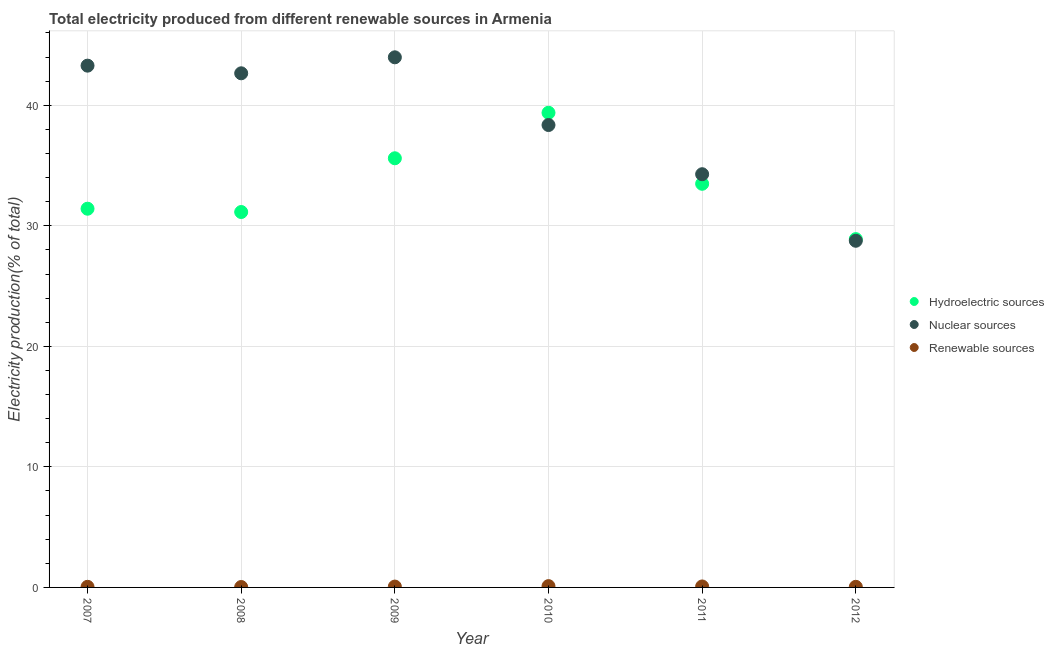How many different coloured dotlines are there?
Offer a terse response. 3. What is the percentage of electricity produced by hydroelectric sources in 2012?
Give a very brief answer. 28.89. Across all years, what is the maximum percentage of electricity produced by hydroelectric sources?
Give a very brief answer. 39.38. Across all years, what is the minimum percentage of electricity produced by hydroelectric sources?
Offer a terse response. 28.89. In which year was the percentage of electricity produced by hydroelectric sources maximum?
Your answer should be compact. 2010. What is the total percentage of electricity produced by hydroelectric sources in the graph?
Your answer should be compact. 199.92. What is the difference between the percentage of electricity produced by nuclear sources in 2011 and that in 2012?
Provide a succinct answer. 5.52. What is the difference between the percentage of electricity produced by nuclear sources in 2011 and the percentage of electricity produced by renewable sources in 2009?
Your response must be concise. 34.21. What is the average percentage of electricity produced by renewable sources per year?
Make the answer very short. 0.07. In the year 2012, what is the difference between the percentage of electricity produced by nuclear sources and percentage of electricity produced by hydroelectric sources?
Provide a short and direct response. -0.14. What is the ratio of the percentage of electricity produced by renewable sources in 2007 to that in 2012?
Your answer should be very brief. 1.02. Is the difference between the percentage of electricity produced by hydroelectric sources in 2011 and 2012 greater than the difference between the percentage of electricity produced by nuclear sources in 2011 and 2012?
Provide a short and direct response. No. What is the difference between the highest and the second highest percentage of electricity produced by renewable sources?
Your response must be concise. 0.03. What is the difference between the highest and the lowest percentage of electricity produced by renewable sources?
Make the answer very short. 0.07. Is the sum of the percentage of electricity produced by nuclear sources in 2007 and 2010 greater than the maximum percentage of electricity produced by renewable sources across all years?
Your response must be concise. Yes. How many dotlines are there?
Your answer should be compact. 3. How many years are there in the graph?
Provide a succinct answer. 6. What is the difference between two consecutive major ticks on the Y-axis?
Ensure brevity in your answer.  10. Are the values on the major ticks of Y-axis written in scientific E-notation?
Keep it short and to the point. No. How many legend labels are there?
Your response must be concise. 3. How are the legend labels stacked?
Your response must be concise. Vertical. What is the title of the graph?
Your response must be concise. Total electricity produced from different renewable sources in Armenia. What is the label or title of the X-axis?
Your response must be concise. Year. What is the label or title of the Y-axis?
Offer a very short reply. Electricity production(% of total). What is the Electricity production(% of total) in Hydroelectric sources in 2007?
Ensure brevity in your answer.  31.42. What is the Electricity production(% of total) in Nuclear sources in 2007?
Make the answer very short. 43.29. What is the Electricity production(% of total) in Renewable sources in 2007?
Provide a succinct answer. 0.05. What is the Electricity production(% of total) in Hydroelectric sources in 2008?
Your answer should be compact. 31.14. What is the Electricity production(% of total) of Nuclear sources in 2008?
Ensure brevity in your answer.  42.65. What is the Electricity production(% of total) of Renewable sources in 2008?
Your answer should be very brief. 0.03. What is the Electricity production(% of total) in Hydroelectric sources in 2009?
Provide a succinct answer. 35.6. What is the Electricity production(% of total) in Nuclear sources in 2009?
Keep it short and to the point. 43.98. What is the Electricity production(% of total) of Renewable sources in 2009?
Provide a short and direct response. 0.07. What is the Electricity production(% of total) in Hydroelectric sources in 2010?
Offer a terse response. 39.38. What is the Electricity production(% of total) in Nuclear sources in 2010?
Your answer should be very brief. 38.36. What is the Electricity production(% of total) in Renewable sources in 2010?
Offer a very short reply. 0.11. What is the Electricity production(% of total) in Hydroelectric sources in 2011?
Provide a succinct answer. 33.49. What is the Electricity production(% of total) in Nuclear sources in 2011?
Provide a short and direct response. 34.28. What is the Electricity production(% of total) of Renewable sources in 2011?
Offer a very short reply. 0.08. What is the Electricity production(% of total) in Hydroelectric sources in 2012?
Your response must be concise. 28.89. What is the Electricity production(% of total) in Nuclear sources in 2012?
Make the answer very short. 28.76. What is the Electricity production(% of total) of Renewable sources in 2012?
Keep it short and to the point. 0.05. Across all years, what is the maximum Electricity production(% of total) of Hydroelectric sources?
Your response must be concise. 39.38. Across all years, what is the maximum Electricity production(% of total) in Nuclear sources?
Your response must be concise. 43.98. Across all years, what is the maximum Electricity production(% of total) in Renewable sources?
Keep it short and to the point. 0.11. Across all years, what is the minimum Electricity production(% of total) of Hydroelectric sources?
Make the answer very short. 28.89. Across all years, what is the minimum Electricity production(% of total) in Nuclear sources?
Ensure brevity in your answer.  28.76. Across all years, what is the minimum Electricity production(% of total) in Renewable sources?
Offer a very short reply. 0.03. What is the total Electricity production(% of total) in Hydroelectric sources in the graph?
Make the answer very short. 199.92. What is the total Electricity production(% of total) of Nuclear sources in the graph?
Offer a very short reply. 231.31. What is the total Electricity production(% of total) of Renewable sources in the graph?
Your response must be concise. 0.39. What is the difference between the Electricity production(% of total) of Hydroelectric sources in 2007 and that in 2008?
Ensure brevity in your answer.  0.27. What is the difference between the Electricity production(% of total) of Nuclear sources in 2007 and that in 2008?
Provide a succinct answer. 0.63. What is the difference between the Electricity production(% of total) of Renewable sources in 2007 and that in 2008?
Provide a succinct answer. 0.02. What is the difference between the Electricity production(% of total) in Hydroelectric sources in 2007 and that in 2009?
Offer a very short reply. -4.18. What is the difference between the Electricity production(% of total) of Nuclear sources in 2007 and that in 2009?
Your answer should be compact. -0.69. What is the difference between the Electricity production(% of total) of Renewable sources in 2007 and that in 2009?
Your answer should be very brief. -0.02. What is the difference between the Electricity production(% of total) in Hydroelectric sources in 2007 and that in 2010?
Your answer should be compact. -7.96. What is the difference between the Electricity production(% of total) in Nuclear sources in 2007 and that in 2010?
Make the answer very short. 4.93. What is the difference between the Electricity production(% of total) in Renewable sources in 2007 and that in 2010?
Give a very brief answer. -0.06. What is the difference between the Electricity production(% of total) in Hydroelectric sources in 2007 and that in 2011?
Your answer should be compact. -2.07. What is the difference between the Electricity production(% of total) in Nuclear sources in 2007 and that in 2011?
Provide a succinct answer. 9.01. What is the difference between the Electricity production(% of total) in Renewable sources in 2007 and that in 2011?
Provide a succinct answer. -0.03. What is the difference between the Electricity production(% of total) in Hydroelectric sources in 2007 and that in 2012?
Your answer should be compact. 2.52. What is the difference between the Electricity production(% of total) in Nuclear sources in 2007 and that in 2012?
Keep it short and to the point. 14.53. What is the difference between the Electricity production(% of total) of Renewable sources in 2007 and that in 2012?
Provide a short and direct response. 0. What is the difference between the Electricity production(% of total) in Hydroelectric sources in 2008 and that in 2009?
Provide a succinct answer. -4.46. What is the difference between the Electricity production(% of total) in Nuclear sources in 2008 and that in 2009?
Provide a succinct answer. -1.33. What is the difference between the Electricity production(% of total) in Renewable sources in 2008 and that in 2009?
Provide a short and direct response. -0.04. What is the difference between the Electricity production(% of total) in Hydroelectric sources in 2008 and that in 2010?
Offer a terse response. -8.23. What is the difference between the Electricity production(% of total) of Nuclear sources in 2008 and that in 2010?
Provide a short and direct response. 4.29. What is the difference between the Electricity production(% of total) in Renewable sources in 2008 and that in 2010?
Give a very brief answer. -0.07. What is the difference between the Electricity production(% of total) in Hydroelectric sources in 2008 and that in 2011?
Keep it short and to the point. -2.34. What is the difference between the Electricity production(% of total) of Nuclear sources in 2008 and that in 2011?
Your answer should be very brief. 8.37. What is the difference between the Electricity production(% of total) in Renewable sources in 2008 and that in 2011?
Make the answer very short. -0.05. What is the difference between the Electricity production(% of total) in Hydroelectric sources in 2008 and that in 2012?
Your response must be concise. 2.25. What is the difference between the Electricity production(% of total) in Nuclear sources in 2008 and that in 2012?
Provide a succinct answer. 13.89. What is the difference between the Electricity production(% of total) of Renewable sources in 2008 and that in 2012?
Your answer should be compact. -0.02. What is the difference between the Electricity production(% of total) in Hydroelectric sources in 2009 and that in 2010?
Ensure brevity in your answer.  -3.78. What is the difference between the Electricity production(% of total) of Nuclear sources in 2009 and that in 2010?
Your answer should be very brief. 5.62. What is the difference between the Electricity production(% of total) in Renewable sources in 2009 and that in 2010?
Your answer should be compact. -0.04. What is the difference between the Electricity production(% of total) of Hydroelectric sources in 2009 and that in 2011?
Ensure brevity in your answer.  2.12. What is the difference between the Electricity production(% of total) of Nuclear sources in 2009 and that in 2011?
Offer a very short reply. 9.7. What is the difference between the Electricity production(% of total) of Renewable sources in 2009 and that in 2011?
Your response must be concise. -0.01. What is the difference between the Electricity production(% of total) in Hydroelectric sources in 2009 and that in 2012?
Keep it short and to the point. 6.71. What is the difference between the Electricity production(% of total) in Nuclear sources in 2009 and that in 2012?
Your answer should be very brief. 15.22. What is the difference between the Electricity production(% of total) of Renewable sources in 2009 and that in 2012?
Ensure brevity in your answer.  0.02. What is the difference between the Electricity production(% of total) of Hydroelectric sources in 2010 and that in 2011?
Make the answer very short. 5.89. What is the difference between the Electricity production(% of total) of Nuclear sources in 2010 and that in 2011?
Your answer should be compact. 4.08. What is the difference between the Electricity production(% of total) of Renewable sources in 2010 and that in 2011?
Offer a terse response. 0.03. What is the difference between the Electricity production(% of total) in Hydroelectric sources in 2010 and that in 2012?
Provide a succinct answer. 10.48. What is the difference between the Electricity production(% of total) in Nuclear sources in 2010 and that in 2012?
Keep it short and to the point. 9.6. What is the difference between the Electricity production(% of total) in Renewable sources in 2010 and that in 2012?
Provide a succinct answer. 0.06. What is the difference between the Electricity production(% of total) in Hydroelectric sources in 2011 and that in 2012?
Your answer should be very brief. 4.59. What is the difference between the Electricity production(% of total) in Nuclear sources in 2011 and that in 2012?
Your answer should be compact. 5.52. What is the difference between the Electricity production(% of total) in Renewable sources in 2011 and that in 2012?
Provide a succinct answer. 0.03. What is the difference between the Electricity production(% of total) in Hydroelectric sources in 2007 and the Electricity production(% of total) in Nuclear sources in 2008?
Offer a very short reply. -11.23. What is the difference between the Electricity production(% of total) in Hydroelectric sources in 2007 and the Electricity production(% of total) in Renewable sources in 2008?
Offer a very short reply. 31.38. What is the difference between the Electricity production(% of total) in Nuclear sources in 2007 and the Electricity production(% of total) in Renewable sources in 2008?
Offer a very short reply. 43.25. What is the difference between the Electricity production(% of total) in Hydroelectric sources in 2007 and the Electricity production(% of total) in Nuclear sources in 2009?
Keep it short and to the point. -12.56. What is the difference between the Electricity production(% of total) of Hydroelectric sources in 2007 and the Electricity production(% of total) of Renewable sources in 2009?
Your answer should be compact. 31.35. What is the difference between the Electricity production(% of total) in Nuclear sources in 2007 and the Electricity production(% of total) in Renewable sources in 2009?
Provide a succinct answer. 43.22. What is the difference between the Electricity production(% of total) in Hydroelectric sources in 2007 and the Electricity production(% of total) in Nuclear sources in 2010?
Give a very brief answer. -6.94. What is the difference between the Electricity production(% of total) in Hydroelectric sources in 2007 and the Electricity production(% of total) in Renewable sources in 2010?
Your answer should be very brief. 31.31. What is the difference between the Electricity production(% of total) of Nuclear sources in 2007 and the Electricity production(% of total) of Renewable sources in 2010?
Your answer should be compact. 43.18. What is the difference between the Electricity production(% of total) of Hydroelectric sources in 2007 and the Electricity production(% of total) of Nuclear sources in 2011?
Keep it short and to the point. -2.86. What is the difference between the Electricity production(% of total) in Hydroelectric sources in 2007 and the Electricity production(% of total) in Renewable sources in 2011?
Ensure brevity in your answer.  31.34. What is the difference between the Electricity production(% of total) in Nuclear sources in 2007 and the Electricity production(% of total) in Renewable sources in 2011?
Your answer should be compact. 43.21. What is the difference between the Electricity production(% of total) of Hydroelectric sources in 2007 and the Electricity production(% of total) of Nuclear sources in 2012?
Give a very brief answer. 2.66. What is the difference between the Electricity production(% of total) of Hydroelectric sources in 2007 and the Electricity production(% of total) of Renewable sources in 2012?
Keep it short and to the point. 31.37. What is the difference between the Electricity production(% of total) in Nuclear sources in 2007 and the Electricity production(% of total) in Renewable sources in 2012?
Offer a terse response. 43.24. What is the difference between the Electricity production(% of total) in Hydroelectric sources in 2008 and the Electricity production(% of total) in Nuclear sources in 2009?
Provide a succinct answer. -12.83. What is the difference between the Electricity production(% of total) of Hydroelectric sources in 2008 and the Electricity production(% of total) of Renewable sources in 2009?
Provide a short and direct response. 31.07. What is the difference between the Electricity production(% of total) of Nuclear sources in 2008 and the Electricity production(% of total) of Renewable sources in 2009?
Offer a terse response. 42.58. What is the difference between the Electricity production(% of total) in Hydroelectric sources in 2008 and the Electricity production(% of total) in Nuclear sources in 2010?
Keep it short and to the point. -7.22. What is the difference between the Electricity production(% of total) in Hydroelectric sources in 2008 and the Electricity production(% of total) in Renewable sources in 2010?
Your answer should be compact. 31.04. What is the difference between the Electricity production(% of total) of Nuclear sources in 2008 and the Electricity production(% of total) of Renewable sources in 2010?
Your response must be concise. 42.54. What is the difference between the Electricity production(% of total) of Hydroelectric sources in 2008 and the Electricity production(% of total) of Nuclear sources in 2011?
Your answer should be very brief. -3.14. What is the difference between the Electricity production(% of total) in Hydroelectric sources in 2008 and the Electricity production(% of total) in Renewable sources in 2011?
Your response must be concise. 31.06. What is the difference between the Electricity production(% of total) in Nuclear sources in 2008 and the Electricity production(% of total) in Renewable sources in 2011?
Give a very brief answer. 42.57. What is the difference between the Electricity production(% of total) in Hydroelectric sources in 2008 and the Electricity production(% of total) in Nuclear sources in 2012?
Provide a short and direct response. 2.39. What is the difference between the Electricity production(% of total) of Hydroelectric sources in 2008 and the Electricity production(% of total) of Renewable sources in 2012?
Your answer should be compact. 31.09. What is the difference between the Electricity production(% of total) in Nuclear sources in 2008 and the Electricity production(% of total) in Renewable sources in 2012?
Ensure brevity in your answer.  42.6. What is the difference between the Electricity production(% of total) of Hydroelectric sources in 2009 and the Electricity production(% of total) of Nuclear sources in 2010?
Provide a short and direct response. -2.76. What is the difference between the Electricity production(% of total) in Hydroelectric sources in 2009 and the Electricity production(% of total) in Renewable sources in 2010?
Provide a short and direct response. 35.49. What is the difference between the Electricity production(% of total) in Nuclear sources in 2009 and the Electricity production(% of total) in Renewable sources in 2010?
Provide a short and direct response. 43.87. What is the difference between the Electricity production(% of total) of Hydroelectric sources in 2009 and the Electricity production(% of total) of Nuclear sources in 2011?
Your response must be concise. 1.32. What is the difference between the Electricity production(% of total) in Hydroelectric sources in 2009 and the Electricity production(% of total) in Renewable sources in 2011?
Make the answer very short. 35.52. What is the difference between the Electricity production(% of total) in Nuclear sources in 2009 and the Electricity production(% of total) in Renewable sources in 2011?
Your answer should be compact. 43.9. What is the difference between the Electricity production(% of total) in Hydroelectric sources in 2009 and the Electricity production(% of total) in Nuclear sources in 2012?
Keep it short and to the point. 6.84. What is the difference between the Electricity production(% of total) of Hydroelectric sources in 2009 and the Electricity production(% of total) of Renewable sources in 2012?
Provide a short and direct response. 35.55. What is the difference between the Electricity production(% of total) in Nuclear sources in 2009 and the Electricity production(% of total) in Renewable sources in 2012?
Your answer should be compact. 43.93. What is the difference between the Electricity production(% of total) in Hydroelectric sources in 2010 and the Electricity production(% of total) in Nuclear sources in 2011?
Offer a terse response. 5.1. What is the difference between the Electricity production(% of total) in Hydroelectric sources in 2010 and the Electricity production(% of total) in Renewable sources in 2011?
Make the answer very short. 39.3. What is the difference between the Electricity production(% of total) in Nuclear sources in 2010 and the Electricity production(% of total) in Renewable sources in 2011?
Offer a terse response. 38.28. What is the difference between the Electricity production(% of total) of Hydroelectric sources in 2010 and the Electricity production(% of total) of Nuclear sources in 2012?
Ensure brevity in your answer.  10.62. What is the difference between the Electricity production(% of total) of Hydroelectric sources in 2010 and the Electricity production(% of total) of Renewable sources in 2012?
Your answer should be compact. 39.33. What is the difference between the Electricity production(% of total) of Nuclear sources in 2010 and the Electricity production(% of total) of Renewable sources in 2012?
Make the answer very short. 38.31. What is the difference between the Electricity production(% of total) in Hydroelectric sources in 2011 and the Electricity production(% of total) in Nuclear sources in 2012?
Your answer should be very brief. 4.73. What is the difference between the Electricity production(% of total) in Hydroelectric sources in 2011 and the Electricity production(% of total) in Renewable sources in 2012?
Provide a succinct answer. 33.44. What is the difference between the Electricity production(% of total) of Nuclear sources in 2011 and the Electricity production(% of total) of Renewable sources in 2012?
Offer a terse response. 34.23. What is the average Electricity production(% of total) of Hydroelectric sources per year?
Ensure brevity in your answer.  33.32. What is the average Electricity production(% of total) of Nuclear sources per year?
Make the answer very short. 38.55. What is the average Electricity production(% of total) of Renewable sources per year?
Your response must be concise. 0.07. In the year 2007, what is the difference between the Electricity production(% of total) of Hydroelectric sources and Electricity production(% of total) of Nuclear sources?
Provide a short and direct response. -11.87. In the year 2007, what is the difference between the Electricity production(% of total) of Hydroelectric sources and Electricity production(% of total) of Renewable sources?
Keep it short and to the point. 31.37. In the year 2007, what is the difference between the Electricity production(% of total) of Nuclear sources and Electricity production(% of total) of Renewable sources?
Offer a terse response. 43.23. In the year 2008, what is the difference between the Electricity production(% of total) of Hydroelectric sources and Electricity production(% of total) of Nuclear sources?
Provide a succinct answer. -11.51. In the year 2008, what is the difference between the Electricity production(% of total) in Hydroelectric sources and Electricity production(% of total) in Renewable sources?
Offer a very short reply. 31.11. In the year 2008, what is the difference between the Electricity production(% of total) of Nuclear sources and Electricity production(% of total) of Renewable sources?
Make the answer very short. 42.62. In the year 2009, what is the difference between the Electricity production(% of total) in Hydroelectric sources and Electricity production(% of total) in Nuclear sources?
Make the answer very short. -8.38. In the year 2009, what is the difference between the Electricity production(% of total) in Hydroelectric sources and Electricity production(% of total) in Renewable sources?
Make the answer very short. 35.53. In the year 2009, what is the difference between the Electricity production(% of total) of Nuclear sources and Electricity production(% of total) of Renewable sources?
Provide a succinct answer. 43.91. In the year 2010, what is the difference between the Electricity production(% of total) in Hydroelectric sources and Electricity production(% of total) in Nuclear sources?
Offer a terse response. 1.02. In the year 2010, what is the difference between the Electricity production(% of total) of Hydroelectric sources and Electricity production(% of total) of Renewable sources?
Provide a succinct answer. 39.27. In the year 2010, what is the difference between the Electricity production(% of total) of Nuclear sources and Electricity production(% of total) of Renewable sources?
Your response must be concise. 38.25. In the year 2011, what is the difference between the Electricity production(% of total) of Hydroelectric sources and Electricity production(% of total) of Nuclear sources?
Keep it short and to the point. -0.79. In the year 2011, what is the difference between the Electricity production(% of total) of Hydroelectric sources and Electricity production(% of total) of Renewable sources?
Ensure brevity in your answer.  33.41. In the year 2011, what is the difference between the Electricity production(% of total) of Nuclear sources and Electricity production(% of total) of Renewable sources?
Ensure brevity in your answer.  34.2. In the year 2012, what is the difference between the Electricity production(% of total) in Hydroelectric sources and Electricity production(% of total) in Nuclear sources?
Give a very brief answer. 0.14. In the year 2012, what is the difference between the Electricity production(% of total) of Hydroelectric sources and Electricity production(% of total) of Renewable sources?
Your answer should be compact. 28.85. In the year 2012, what is the difference between the Electricity production(% of total) of Nuclear sources and Electricity production(% of total) of Renewable sources?
Ensure brevity in your answer.  28.71. What is the ratio of the Electricity production(% of total) of Hydroelectric sources in 2007 to that in 2008?
Your answer should be compact. 1.01. What is the ratio of the Electricity production(% of total) of Nuclear sources in 2007 to that in 2008?
Your answer should be compact. 1.01. What is the ratio of the Electricity production(% of total) in Renewable sources in 2007 to that in 2008?
Your response must be concise. 1.47. What is the ratio of the Electricity production(% of total) in Hydroelectric sources in 2007 to that in 2009?
Provide a succinct answer. 0.88. What is the ratio of the Electricity production(% of total) of Nuclear sources in 2007 to that in 2009?
Make the answer very short. 0.98. What is the ratio of the Electricity production(% of total) in Renewable sources in 2007 to that in 2009?
Offer a very short reply. 0.72. What is the ratio of the Electricity production(% of total) in Hydroelectric sources in 2007 to that in 2010?
Keep it short and to the point. 0.8. What is the ratio of the Electricity production(% of total) of Nuclear sources in 2007 to that in 2010?
Offer a very short reply. 1.13. What is the ratio of the Electricity production(% of total) of Renewable sources in 2007 to that in 2010?
Your response must be concise. 0.47. What is the ratio of the Electricity production(% of total) in Hydroelectric sources in 2007 to that in 2011?
Your answer should be very brief. 0.94. What is the ratio of the Electricity production(% of total) in Nuclear sources in 2007 to that in 2011?
Offer a terse response. 1.26. What is the ratio of the Electricity production(% of total) of Renewable sources in 2007 to that in 2011?
Ensure brevity in your answer.  0.63. What is the ratio of the Electricity production(% of total) of Hydroelectric sources in 2007 to that in 2012?
Your answer should be compact. 1.09. What is the ratio of the Electricity production(% of total) in Nuclear sources in 2007 to that in 2012?
Ensure brevity in your answer.  1.51. What is the ratio of the Electricity production(% of total) of Renewable sources in 2007 to that in 2012?
Make the answer very short. 1.02. What is the ratio of the Electricity production(% of total) in Hydroelectric sources in 2008 to that in 2009?
Your answer should be compact. 0.87. What is the ratio of the Electricity production(% of total) of Nuclear sources in 2008 to that in 2009?
Offer a terse response. 0.97. What is the ratio of the Electricity production(% of total) in Renewable sources in 2008 to that in 2009?
Offer a terse response. 0.49. What is the ratio of the Electricity production(% of total) of Hydroelectric sources in 2008 to that in 2010?
Offer a very short reply. 0.79. What is the ratio of the Electricity production(% of total) of Nuclear sources in 2008 to that in 2010?
Provide a short and direct response. 1.11. What is the ratio of the Electricity production(% of total) in Renewable sources in 2008 to that in 2010?
Your answer should be compact. 0.32. What is the ratio of the Electricity production(% of total) in Hydroelectric sources in 2008 to that in 2011?
Keep it short and to the point. 0.93. What is the ratio of the Electricity production(% of total) in Nuclear sources in 2008 to that in 2011?
Your answer should be compact. 1.24. What is the ratio of the Electricity production(% of total) of Renewable sources in 2008 to that in 2011?
Offer a terse response. 0.43. What is the ratio of the Electricity production(% of total) of Hydroelectric sources in 2008 to that in 2012?
Ensure brevity in your answer.  1.08. What is the ratio of the Electricity production(% of total) of Nuclear sources in 2008 to that in 2012?
Keep it short and to the point. 1.48. What is the ratio of the Electricity production(% of total) in Renewable sources in 2008 to that in 2012?
Keep it short and to the point. 0.7. What is the ratio of the Electricity production(% of total) in Hydroelectric sources in 2009 to that in 2010?
Provide a short and direct response. 0.9. What is the ratio of the Electricity production(% of total) of Nuclear sources in 2009 to that in 2010?
Make the answer very short. 1.15. What is the ratio of the Electricity production(% of total) of Renewable sources in 2009 to that in 2010?
Ensure brevity in your answer.  0.65. What is the ratio of the Electricity production(% of total) in Hydroelectric sources in 2009 to that in 2011?
Offer a terse response. 1.06. What is the ratio of the Electricity production(% of total) of Nuclear sources in 2009 to that in 2011?
Your response must be concise. 1.28. What is the ratio of the Electricity production(% of total) of Renewable sources in 2009 to that in 2011?
Your response must be concise. 0.87. What is the ratio of the Electricity production(% of total) in Hydroelectric sources in 2009 to that in 2012?
Provide a succinct answer. 1.23. What is the ratio of the Electricity production(% of total) in Nuclear sources in 2009 to that in 2012?
Offer a terse response. 1.53. What is the ratio of the Electricity production(% of total) of Renewable sources in 2009 to that in 2012?
Offer a terse response. 1.42. What is the ratio of the Electricity production(% of total) in Hydroelectric sources in 2010 to that in 2011?
Give a very brief answer. 1.18. What is the ratio of the Electricity production(% of total) of Nuclear sources in 2010 to that in 2011?
Provide a succinct answer. 1.12. What is the ratio of the Electricity production(% of total) in Renewable sources in 2010 to that in 2011?
Make the answer very short. 1.34. What is the ratio of the Electricity production(% of total) in Hydroelectric sources in 2010 to that in 2012?
Keep it short and to the point. 1.36. What is the ratio of the Electricity production(% of total) of Nuclear sources in 2010 to that in 2012?
Your answer should be compact. 1.33. What is the ratio of the Electricity production(% of total) in Renewable sources in 2010 to that in 2012?
Your answer should be very brief. 2.17. What is the ratio of the Electricity production(% of total) of Hydroelectric sources in 2011 to that in 2012?
Offer a terse response. 1.16. What is the ratio of the Electricity production(% of total) in Nuclear sources in 2011 to that in 2012?
Keep it short and to the point. 1.19. What is the ratio of the Electricity production(% of total) in Renewable sources in 2011 to that in 2012?
Give a very brief answer. 1.62. What is the difference between the highest and the second highest Electricity production(% of total) in Hydroelectric sources?
Ensure brevity in your answer.  3.78. What is the difference between the highest and the second highest Electricity production(% of total) in Nuclear sources?
Offer a very short reply. 0.69. What is the difference between the highest and the second highest Electricity production(% of total) in Renewable sources?
Make the answer very short. 0.03. What is the difference between the highest and the lowest Electricity production(% of total) in Hydroelectric sources?
Your response must be concise. 10.48. What is the difference between the highest and the lowest Electricity production(% of total) of Nuclear sources?
Your answer should be compact. 15.22. What is the difference between the highest and the lowest Electricity production(% of total) in Renewable sources?
Provide a short and direct response. 0.07. 